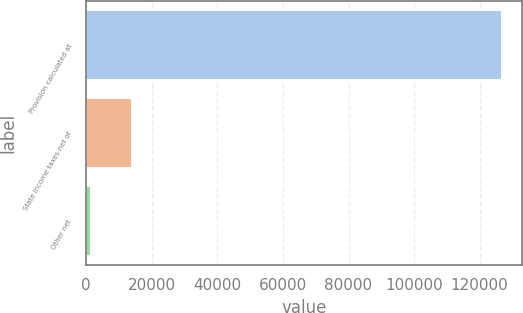Convert chart. <chart><loc_0><loc_0><loc_500><loc_500><bar_chart><fcel>Provision calculated at<fcel>State income taxes net of<fcel>Other net<nl><fcel>126667<fcel>13900.6<fcel>1371<nl></chart> 